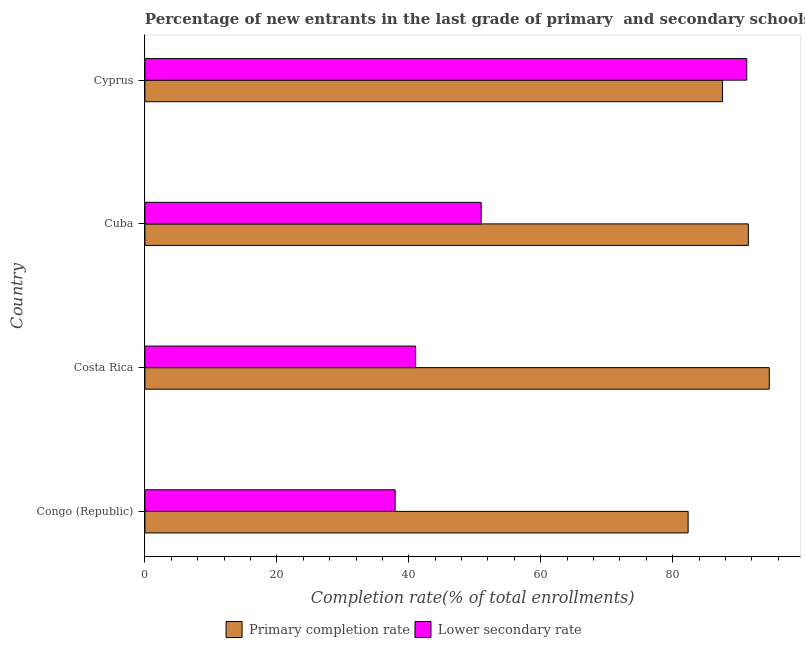How many different coloured bars are there?
Ensure brevity in your answer.  2. Are the number of bars per tick equal to the number of legend labels?
Provide a short and direct response. Yes. What is the label of the 2nd group of bars from the top?
Offer a very short reply. Cuba. What is the completion rate in primary schools in Cuba?
Your response must be concise. 91.48. Across all countries, what is the maximum completion rate in primary schools?
Provide a succinct answer. 94.65. Across all countries, what is the minimum completion rate in primary schools?
Provide a succinct answer. 82.35. In which country was the completion rate in primary schools maximum?
Provide a succinct answer. Costa Rica. In which country was the completion rate in primary schools minimum?
Provide a succinct answer. Congo (Republic). What is the total completion rate in secondary schools in the graph?
Provide a succinct answer. 221.18. What is the difference between the completion rate in primary schools in Cuba and that in Cyprus?
Ensure brevity in your answer.  3.93. What is the difference between the completion rate in secondary schools in Costa Rica and the completion rate in primary schools in Cyprus?
Offer a very short reply. -46.51. What is the average completion rate in primary schools per country?
Your answer should be compact. 89.01. What is the difference between the completion rate in primary schools and completion rate in secondary schools in Costa Rica?
Ensure brevity in your answer.  53.61. In how many countries, is the completion rate in primary schools greater than 44 %?
Provide a short and direct response. 4. What is the ratio of the completion rate in secondary schools in Congo (Republic) to that in Cuba?
Your answer should be very brief. 0.74. What is the difference between the highest and the second highest completion rate in secondary schools?
Provide a succinct answer. 40.27. What is the difference between the highest and the lowest completion rate in secondary schools?
Make the answer very short. 53.3. Is the sum of the completion rate in primary schools in Costa Rica and Cyprus greater than the maximum completion rate in secondary schools across all countries?
Your response must be concise. Yes. What does the 1st bar from the top in Cuba represents?
Give a very brief answer. Lower secondary rate. What does the 1st bar from the bottom in Cyprus represents?
Provide a succinct answer. Primary completion rate. How many bars are there?
Provide a succinct answer. 8. Are the values on the major ticks of X-axis written in scientific E-notation?
Your response must be concise. No. Where does the legend appear in the graph?
Your response must be concise. Bottom center. How are the legend labels stacked?
Offer a very short reply. Horizontal. What is the title of the graph?
Provide a short and direct response. Percentage of new entrants in the last grade of primary  and secondary schools in countries. What is the label or title of the X-axis?
Your response must be concise. Completion rate(% of total enrollments). What is the Completion rate(% of total enrollments) of Primary completion rate in Congo (Republic)?
Your answer should be compact. 82.35. What is the Completion rate(% of total enrollments) of Lower secondary rate in Congo (Republic)?
Ensure brevity in your answer.  37.93. What is the Completion rate(% of total enrollments) of Primary completion rate in Costa Rica?
Offer a terse response. 94.65. What is the Completion rate(% of total enrollments) of Lower secondary rate in Costa Rica?
Ensure brevity in your answer.  41.04. What is the Completion rate(% of total enrollments) in Primary completion rate in Cuba?
Offer a terse response. 91.48. What is the Completion rate(% of total enrollments) of Lower secondary rate in Cuba?
Provide a short and direct response. 50.97. What is the Completion rate(% of total enrollments) in Primary completion rate in Cyprus?
Your answer should be compact. 87.55. What is the Completion rate(% of total enrollments) in Lower secondary rate in Cyprus?
Provide a succinct answer. 91.24. Across all countries, what is the maximum Completion rate(% of total enrollments) of Primary completion rate?
Your answer should be very brief. 94.65. Across all countries, what is the maximum Completion rate(% of total enrollments) in Lower secondary rate?
Ensure brevity in your answer.  91.24. Across all countries, what is the minimum Completion rate(% of total enrollments) in Primary completion rate?
Ensure brevity in your answer.  82.35. Across all countries, what is the minimum Completion rate(% of total enrollments) in Lower secondary rate?
Give a very brief answer. 37.93. What is the total Completion rate(% of total enrollments) in Primary completion rate in the graph?
Your answer should be compact. 356.03. What is the total Completion rate(% of total enrollments) in Lower secondary rate in the graph?
Make the answer very short. 221.18. What is the difference between the Completion rate(% of total enrollments) in Primary completion rate in Congo (Republic) and that in Costa Rica?
Offer a terse response. -12.3. What is the difference between the Completion rate(% of total enrollments) of Lower secondary rate in Congo (Republic) and that in Costa Rica?
Make the answer very short. -3.11. What is the difference between the Completion rate(% of total enrollments) of Primary completion rate in Congo (Republic) and that in Cuba?
Offer a terse response. -9.13. What is the difference between the Completion rate(% of total enrollments) of Lower secondary rate in Congo (Republic) and that in Cuba?
Offer a very short reply. -13.04. What is the difference between the Completion rate(% of total enrollments) in Primary completion rate in Congo (Republic) and that in Cyprus?
Offer a very short reply. -5.2. What is the difference between the Completion rate(% of total enrollments) in Lower secondary rate in Congo (Republic) and that in Cyprus?
Your answer should be very brief. -53.3. What is the difference between the Completion rate(% of total enrollments) in Primary completion rate in Costa Rica and that in Cuba?
Offer a terse response. 3.17. What is the difference between the Completion rate(% of total enrollments) in Lower secondary rate in Costa Rica and that in Cuba?
Provide a succinct answer. -9.93. What is the difference between the Completion rate(% of total enrollments) of Primary completion rate in Costa Rica and that in Cyprus?
Your answer should be very brief. 7.1. What is the difference between the Completion rate(% of total enrollments) in Lower secondary rate in Costa Rica and that in Cyprus?
Give a very brief answer. -50.2. What is the difference between the Completion rate(% of total enrollments) of Primary completion rate in Cuba and that in Cyprus?
Provide a succinct answer. 3.93. What is the difference between the Completion rate(% of total enrollments) of Lower secondary rate in Cuba and that in Cyprus?
Offer a very short reply. -40.27. What is the difference between the Completion rate(% of total enrollments) in Primary completion rate in Congo (Republic) and the Completion rate(% of total enrollments) in Lower secondary rate in Costa Rica?
Provide a short and direct response. 41.31. What is the difference between the Completion rate(% of total enrollments) in Primary completion rate in Congo (Republic) and the Completion rate(% of total enrollments) in Lower secondary rate in Cuba?
Offer a terse response. 31.38. What is the difference between the Completion rate(% of total enrollments) of Primary completion rate in Congo (Republic) and the Completion rate(% of total enrollments) of Lower secondary rate in Cyprus?
Offer a terse response. -8.89. What is the difference between the Completion rate(% of total enrollments) in Primary completion rate in Costa Rica and the Completion rate(% of total enrollments) in Lower secondary rate in Cuba?
Give a very brief answer. 43.68. What is the difference between the Completion rate(% of total enrollments) of Primary completion rate in Costa Rica and the Completion rate(% of total enrollments) of Lower secondary rate in Cyprus?
Your response must be concise. 3.41. What is the difference between the Completion rate(% of total enrollments) of Primary completion rate in Cuba and the Completion rate(% of total enrollments) of Lower secondary rate in Cyprus?
Your answer should be compact. 0.24. What is the average Completion rate(% of total enrollments) in Primary completion rate per country?
Keep it short and to the point. 89.01. What is the average Completion rate(% of total enrollments) of Lower secondary rate per country?
Offer a terse response. 55.29. What is the difference between the Completion rate(% of total enrollments) in Primary completion rate and Completion rate(% of total enrollments) in Lower secondary rate in Congo (Republic)?
Provide a succinct answer. 44.42. What is the difference between the Completion rate(% of total enrollments) of Primary completion rate and Completion rate(% of total enrollments) of Lower secondary rate in Costa Rica?
Offer a terse response. 53.61. What is the difference between the Completion rate(% of total enrollments) in Primary completion rate and Completion rate(% of total enrollments) in Lower secondary rate in Cuba?
Ensure brevity in your answer.  40.51. What is the difference between the Completion rate(% of total enrollments) in Primary completion rate and Completion rate(% of total enrollments) in Lower secondary rate in Cyprus?
Ensure brevity in your answer.  -3.68. What is the ratio of the Completion rate(% of total enrollments) of Primary completion rate in Congo (Republic) to that in Costa Rica?
Keep it short and to the point. 0.87. What is the ratio of the Completion rate(% of total enrollments) in Lower secondary rate in Congo (Republic) to that in Costa Rica?
Provide a succinct answer. 0.92. What is the ratio of the Completion rate(% of total enrollments) of Primary completion rate in Congo (Republic) to that in Cuba?
Keep it short and to the point. 0.9. What is the ratio of the Completion rate(% of total enrollments) of Lower secondary rate in Congo (Republic) to that in Cuba?
Offer a very short reply. 0.74. What is the ratio of the Completion rate(% of total enrollments) in Primary completion rate in Congo (Republic) to that in Cyprus?
Keep it short and to the point. 0.94. What is the ratio of the Completion rate(% of total enrollments) of Lower secondary rate in Congo (Republic) to that in Cyprus?
Keep it short and to the point. 0.42. What is the ratio of the Completion rate(% of total enrollments) of Primary completion rate in Costa Rica to that in Cuba?
Offer a terse response. 1.03. What is the ratio of the Completion rate(% of total enrollments) of Lower secondary rate in Costa Rica to that in Cuba?
Offer a very short reply. 0.81. What is the ratio of the Completion rate(% of total enrollments) in Primary completion rate in Costa Rica to that in Cyprus?
Ensure brevity in your answer.  1.08. What is the ratio of the Completion rate(% of total enrollments) of Lower secondary rate in Costa Rica to that in Cyprus?
Give a very brief answer. 0.45. What is the ratio of the Completion rate(% of total enrollments) of Primary completion rate in Cuba to that in Cyprus?
Ensure brevity in your answer.  1.04. What is the ratio of the Completion rate(% of total enrollments) in Lower secondary rate in Cuba to that in Cyprus?
Offer a very short reply. 0.56. What is the difference between the highest and the second highest Completion rate(% of total enrollments) in Primary completion rate?
Offer a very short reply. 3.17. What is the difference between the highest and the second highest Completion rate(% of total enrollments) of Lower secondary rate?
Your answer should be very brief. 40.27. What is the difference between the highest and the lowest Completion rate(% of total enrollments) of Primary completion rate?
Make the answer very short. 12.3. What is the difference between the highest and the lowest Completion rate(% of total enrollments) in Lower secondary rate?
Make the answer very short. 53.3. 